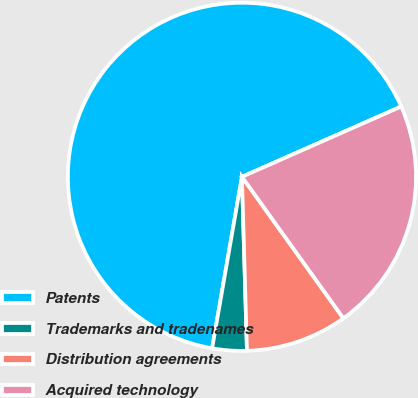<chart> <loc_0><loc_0><loc_500><loc_500><pie_chart><fcel>Patents<fcel>Trademarks and tradenames<fcel>Distribution agreements<fcel>Acquired technology<nl><fcel>65.65%<fcel>3.2%<fcel>9.44%<fcel>21.72%<nl></chart> 